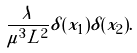Convert formula to latex. <formula><loc_0><loc_0><loc_500><loc_500>\frac { \lambda } { \mu ^ { 3 } L ^ { 2 } } \delta ( x _ { 1 } ) \delta ( x _ { 2 } ) .</formula> 